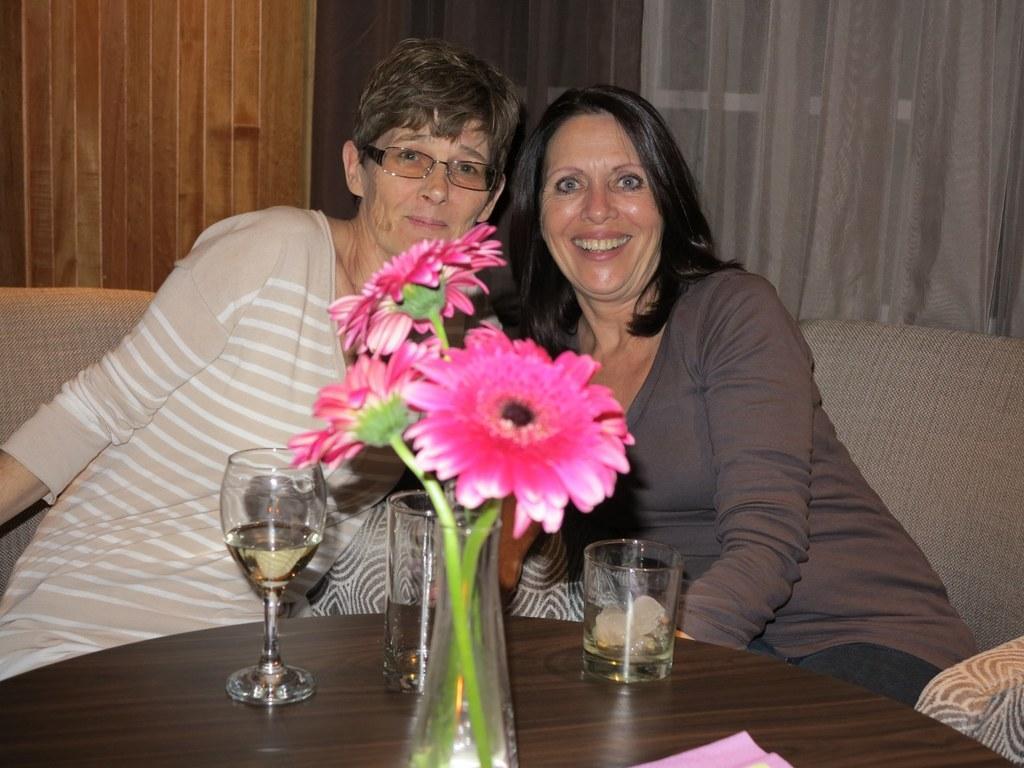How would you summarize this image in a sentence or two? In the foreground of this image, there is a flower vase and three glasses on the wooden table. In the background, there are two women sitting on the couch, curtain, window and the wall. 